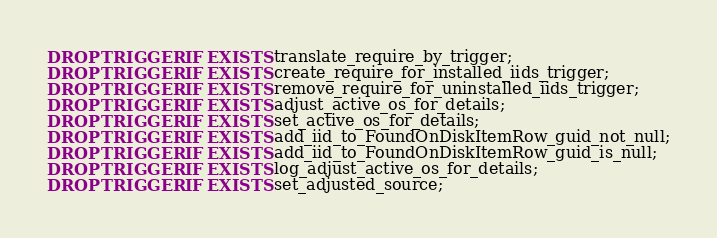<code> <loc_0><loc_0><loc_500><loc_500><_SQL_>DROP TRIGGER IF EXISTS translate_require_by_trigger;
DROP TRIGGER IF EXISTS create_require_for_installed_iids_trigger;
DROP TRIGGER IF EXISTS remove_require_for_uninstalled_iids_trigger;
DROP TRIGGER IF EXISTS adjust_active_os_for_details;
DROP TRIGGER IF EXISTS set_active_os_for_details;
DROP TRIGGER IF EXISTS add_iid_to_FoundOnDiskItemRow_guid_not_null;
DROP TRIGGER IF EXISTS add_iid_to_FoundOnDiskItemRow_guid_is_null;
DROP TRIGGER IF EXISTS log_adjust_active_os_for_details;
DROP TRIGGER IF EXISTS set_adjusted_source;
</code> 